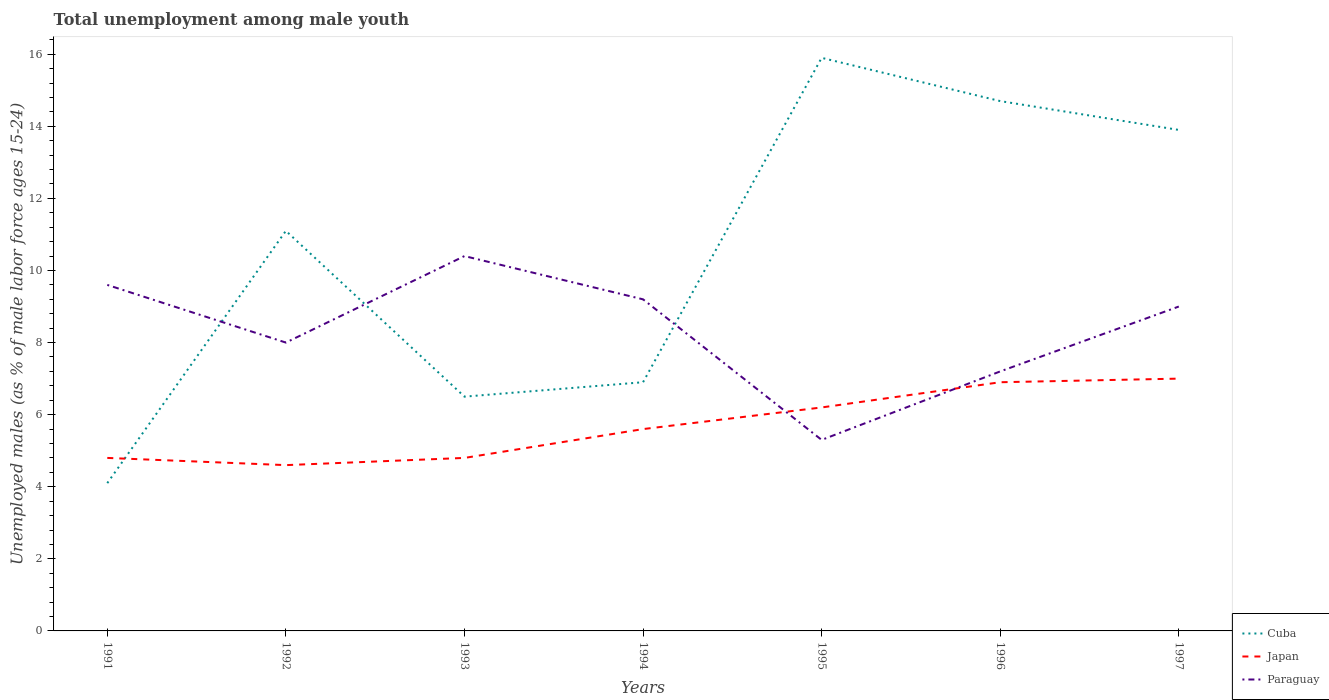Does the line corresponding to Paraguay intersect with the line corresponding to Cuba?
Offer a terse response. Yes. Is the number of lines equal to the number of legend labels?
Your answer should be compact. Yes. Across all years, what is the maximum percentage of unemployed males in in Cuba?
Give a very brief answer. 4.1. In which year was the percentage of unemployed males in in Japan maximum?
Provide a succinct answer. 1992. What is the difference between the highest and the second highest percentage of unemployed males in in Cuba?
Make the answer very short. 11.8. How many lines are there?
Provide a short and direct response. 3. How are the legend labels stacked?
Provide a short and direct response. Vertical. What is the title of the graph?
Provide a short and direct response. Total unemployment among male youth. Does "Kyrgyz Republic" appear as one of the legend labels in the graph?
Your response must be concise. No. What is the label or title of the Y-axis?
Offer a terse response. Unemployed males (as % of male labor force ages 15-24). What is the Unemployed males (as % of male labor force ages 15-24) in Cuba in 1991?
Your answer should be compact. 4.1. What is the Unemployed males (as % of male labor force ages 15-24) of Japan in 1991?
Give a very brief answer. 4.8. What is the Unemployed males (as % of male labor force ages 15-24) in Paraguay in 1991?
Ensure brevity in your answer.  9.6. What is the Unemployed males (as % of male labor force ages 15-24) in Cuba in 1992?
Give a very brief answer. 11.1. What is the Unemployed males (as % of male labor force ages 15-24) of Japan in 1992?
Your answer should be compact. 4.6. What is the Unemployed males (as % of male labor force ages 15-24) in Paraguay in 1992?
Your response must be concise. 8. What is the Unemployed males (as % of male labor force ages 15-24) of Japan in 1993?
Keep it short and to the point. 4.8. What is the Unemployed males (as % of male labor force ages 15-24) in Paraguay in 1993?
Offer a very short reply. 10.4. What is the Unemployed males (as % of male labor force ages 15-24) in Cuba in 1994?
Provide a short and direct response. 6.9. What is the Unemployed males (as % of male labor force ages 15-24) of Japan in 1994?
Give a very brief answer. 5.6. What is the Unemployed males (as % of male labor force ages 15-24) in Paraguay in 1994?
Provide a succinct answer. 9.2. What is the Unemployed males (as % of male labor force ages 15-24) of Cuba in 1995?
Offer a very short reply. 15.9. What is the Unemployed males (as % of male labor force ages 15-24) in Japan in 1995?
Provide a short and direct response. 6.2. What is the Unemployed males (as % of male labor force ages 15-24) in Paraguay in 1995?
Make the answer very short. 5.3. What is the Unemployed males (as % of male labor force ages 15-24) of Cuba in 1996?
Provide a short and direct response. 14.7. What is the Unemployed males (as % of male labor force ages 15-24) in Japan in 1996?
Your response must be concise. 6.9. What is the Unemployed males (as % of male labor force ages 15-24) of Paraguay in 1996?
Your response must be concise. 7.2. What is the Unemployed males (as % of male labor force ages 15-24) of Cuba in 1997?
Provide a succinct answer. 13.9. What is the Unemployed males (as % of male labor force ages 15-24) of Paraguay in 1997?
Offer a very short reply. 9. Across all years, what is the maximum Unemployed males (as % of male labor force ages 15-24) in Cuba?
Offer a terse response. 15.9. Across all years, what is the maximum Unemployed males (as % of male labor force ages 15-24) in Paraguay?
Ensure brevity in your answer.  10.4. Across all years, what is the minimum Unemployed males (as % of male labor force ages 15-24) in Cuba?
Provide a succinct answer. 4.1. Across all years, what is the minimum Unemployed males (as % of male labor force ages 15-24) in Japan?
Your answer should be very brief. 4.6. Across all years, what is the minimum Unemployed males (as % of male labor force ages 15-24) in Paraguay?
Your response must be concise. 5.3. What is the total Unemployed males (as % of male labor force ages 15-24) of Cuba in the graph?
Provide a short and direct response. 73.1. What is the total Unemployed males (as % of male labor force ages 15-24) in Japan in the graph?
Offer a very short reply. 39.9. What is the total Unemployed males (as % of male labor force ages 15-24) in Paraguay in the graph?
Give a very brief answer. 58.7. What is the difference between the Unemployed males (as % of male labor force ages 15-24) of Cuba in 1991 and that in 1994?
Keep it short and to the point. -2.8. What is the difference between the Unemployed males (as % of male labor force ages 15-24) in Japan in 1991 and that in 1994?
Keep it short and to the point. -0.8. What is the difference between the Unemployed males (as % of male labor force ages 15-24) in Paraguay in 1991 and that in 1994?
Ensure brevity in your answer.  0.4. What is the difference between the Unemployed males (as % of male labor force ages 15-24) in Cuba in 1991 and that in 1995?
Provide a short and direct response. -11.8. What is the difference between the Unemployed males (as % of male labor force ages 15-24) of Japan in 1991 and that in 1996?
Your answer should be very brief. -2.1. What is the difference between the Unemployed males (as % of male labor force ages 15-24) in Cuba in 1991 and that in 1997?
Your answer should be very brief. -9.8. What is the difference between the Unemployed males (as % of male labor force ages 15-24) of Japan in 1991 and that in 1997?
Offer a terse response. -2.2. What is the difference between the Unemployed males (as % of male labor force ages 15-24) of Paraguay in 1991 and that in 1997?
Give a very brief answer. 0.6. What is the difference between the Unemployed males (as % of male labor force ages 15-24) in Japan in 1992 and that in 1993?
Keep it short and to the point. -0.2. What is the difference between the Unemployed males (as % of male labor force ages 15-24) in Cuba in 1992 and that in 1994?
Offer a very short reply. 4.2. What is the difference between the Unemployed males (as % of male labor force ages 15-24) of Japan in 1992 and that in 1994?
Keep it short and to the point. -1. What is the difference between the Unemployed males (as % of male labor force ages 15-24) in Paraguay in 1992 and that in 1994?
Make the answer very short. -1.2. What is the difference between the Unemployed males (as % of male labor force ages 15-24) of Cuba in 1992 and that in 1995?
Give a very brief answer. -4.8. What is the difference between the Unemployed males (as % of male labor force ages 15-24) of Japan in 1992 and that in 1995?
Make the answer very short. -1.6. What is the difference between the Unemployed males (as % of male labor force ages 15-24) of Cuba in 1992 and that in 1996?
Give a very brief answer. -3.6. What is the difference between the Unemployed males (as % of male labor force ages 15-24) of Paraguay in 1992 and that in 1996?
Your answer should be compact. 0.8. What is the difference between the Unemployed males (as % of male labor force ages 15-24) in Cuba in 1993 and that in 1994?
Provide a short and direct response. -0.4. What is the difference between the Unemployed males (as % of male labor force ages 15-24) in Paraguay in 1993 and that in 1994?
Your answer should be very brief. 1.2. What is the difference between the Unemployed males (as % of male labor force ages 15-24) in Japan in 1993 and that in 1995?
Ensure brevity in your answer.  -1.4. What is the difference between the Unemployed males (as % of male labor force ages 15-24) in Japan in 1993 and that in 1996?
Your answer should be very brief. -2.1. What is the difference between the Unemployed males (as % of male labor force ages 15-24) of Paraguay in 1993 and that in 1996?
Make the answer very short. 3.2. What is the difference between the Unemployed males (as % of male labor force ages 15-24) of Cuba in 1993 and that in 1997?
Make the answer very short. -7.4. What is the difference between the Unemployed males (as % of male labor force ages 15-24) of Japan in 1994 and that in 1995?
Offer a very short reply. -0.6. What is the difference between the Unemployed males (as % of male labor force ages 15-24) of Paraguay in 1994 and that in 1995?
Give a very brief answer. 3.9. What is the difference between the Unemployed males (as % of male labor force ages 15-24) in Cuba in 1994 and that in 1996?
Make the answer very short. -7.8. What is the difference between the Unemployed males (as % of male labor force ages 15-24) of Japan in 1994 and that in 1996?
Offer a very short reply. -1.3. What is the difference between the Unemployed males (as % of male labor force ages 15-24) of Paraguay in 1994 and that in 1996?
Offer a terse response. 2. What is the difference between the Unemployed males (as % of male labor force ages 15-24) in Cuba in 1994 and that in 1997?
Provide a succinct answer. -7. What is the difference between the Unemployed males (as % of male labor force ages 15-24) of Japan in 1995 and that in 1996?
Offer a very short reply. -0.7. What is the difference between the Unemployed males (as % of male labor force ages 15-24) of Paraguay in 1995 and that in 1996?
Your response must be concise. -1.9. What is the difference between the Unemployed males (as % of male labor force ages 15-24) in Paraguay in 1995 and that in 1997?
Your response must be concise. -3.7. What is the difference between the Unemployed males (as % of male labor force ages 15-24) in Cuba in 1996 and that in 1997?
Provide a succinct answer. 0.8. What is the difference between the Unemployed males (as % of male labor force ages 15-24) of Japan in 1996 and that in 1997?
Provide a succinct answer. -0.1. What is the difference between the Unemployed males (as % of male labor force ages 15-24) of Cuba in 1991 and the Unemployed males (as % of male labor force ages 15-24) of Paraguay in 1992?
Keep it short and to the point. -3.9. What is the difference between the Unemployed males (as % of male labor force ages 15-24) of Japan in 1991 and the Unemployed males (as % of male labor force ages 15-24) of Paraguay in 1992?
Make the answer very short. -3.2. What is the difference between the Unemployed males (as % of male labor force ages 15-24) in Japan in 1991 and the Unemployed males (as % of male labor force ages 15-24) in Paraguay in 1993?
Offer a terse response. -5.6. What is the difference between the Unemployed males (as % of male labor force ages 15-24) of Cuba in 1991 and the Unemployed males (as % of male labor force ages 15-24) of Japan in 1994?
Make the answer very short. -1.5. What is the difference between the Unemployed males (as % of male labor force ages 15-24) of Cuba in 1991 and the Unemployed males (as % of male labor force ages 15-24) of Paraguay in 1994?
Keep it short and to the point. -5.1. What is the difference between the Unemployed males (as % of male labor force ages 15-24) in Japan in 1991 and the Unemployed males (as % of male labor force ages 15-24) in Paraguay in 1994?
Your answer should be compact. -4.4. What is the difference between the Unemployed males (as % of male labor force ages 15-24) of Cuba in 1991 and the Unemployed males (as % of male labor force ages 15-24) of Paraguay in 1995?
Make the answer very short. -1.2. What is the difference between the Unemployed males (as % of male labor force ages 15-24) in Japan in 1991 and the Unemployed males (as % of male labor force ages 15-24) in Paraguay in 1995?
Give a very brief answer. -0.5. What is the difference between the Unemployed males (as % of male labor force ages 15-24) in Cuba in 1991 and the Unemployed males (as % of male labor force ages 15-24) in Japan in 1996?
Offer a terse response. -2.8. What is the difference between the Unemployed males (as % of male labor force ages 15-24) of Cuba in 1991 and the Unemployed males (as % of male labor force ages 15-24) of Paraguay in 1996?
Offer a very short reply. -3.1. What is the difference between the Unemployed males (as % of male labor force ages 15-24) in Japan in 1991 and the Unemployed males (as % of male labor force ages 15-24) in Paraguay in 1996?
Provide a succinct answer. -2.4. What is the difference between the Unemployed males (as % of male labor force ages 15-24) of Cuba in 1991 and the Unemployed males (as % of male labor force ages 15-24) of Japan in 1997?
Provide a short and direct response. -2.9. What is the difference between the Unemployed males (as % of male labor force ages 15-24) in Cuba in 1991 and the Unemployed males (as % of male labor force ages 15-24) in Paraguay in 1997?
Give a very brief answer. -4.9. What is the difference between the Unemployed males (as % of male labor force ages 15-24) of Japan in 1991 and the Unemployed males (as % of male labor force ages 15-24) of Paraguay in 1997?
Ensure brevity in your answer.  -4.2. What is the difference between the Unemployed males (as % of male labor force ages 15-24) in Cuba in 1992 and the Unemployed males (as % of male labor force ages 15-24) in Japan in 1995?
Your answer should be very brief. 4.9. What is the difference between the Unemployed males (as % of male labor force ages 15-24) of Cuba in 1992 and the Unemployed males (as % of male labor force ages 15-24) of Paraguay in 1995?
Ensure brevity in your answer.  5.8. What is the difference between the Unemployed males (as % of male labor force ages 15-24) of Japan in 1992 and the Unemployed males (as % of male labor force ages 15-24) of Paraguay in 1995?
Offer a very short reply. -0.7. What is the difference between the Unemployed males (as % of male labor force ages 15-24) of Cuba in 1992 and the Unemployed males (as % of male labor force ages 15-24) of Paraguay in 1996?
Ensure brevity in your answer.  3.9. What is the difference between the Unemployed males (as % of male labor force ages 15-24) of Japan in 1992 and the Unemployed males (as % of male labor force ages 15-24) of Paraguay in 1996?
Provide a short and direct response. -2.6. What is the difference between the Unemployed males (as % of male labor force ages 15-24) in Cuba in 1992 and the Unemployed males (as % of male labor force ages 15-24) in Japan in 1997?
Ensure brevity in your answer.  4.1. What is the difference between the Unemployed males (as % of male labor force ages 15-24) of Japan in 1992 and the Unemployed males (as % of male labor force ages 15-24) of Paraguay in 1997?
Your answer should be very brief. -4.4. What is the difference between the Unemployed males (as % of male labor force ages 15-24) in Cuba in 1993 and the Unemployed males (as % of male labor force ages 15-24) in Paraguay in 1994?
Give a very brief answer. -2.7. What is the difference between the Unemployed males (as % of male labor force ages 15-24) of Cuba in 1993 and the Unemployed males (as % of male labor force ages 15-24) of Japan in 1996?
Give a very brief answer. -0.4. What is the difference between the Unemployed males (as % of male labor force ages 15-24) of Cuba in 1993 and the Unemployed males (as % of male labor force ages 15-24) of Paraguay in 1996?
Keep it short and to the point. -0.7. What is the difference between the Unemployed males (as % of male labor force ages 15-24) of Cuba in 1993 and the Unemployed males (as % of male labor force ages 15-24) of Paraguay in 1997?
Give a very brief answer. -2.5. What is the difference between the Unemployed males (as % of male labor force ages 15-24) of Japan in 1993 and the Unemployed males (as % of male labor force ages 15-24) of Paraguay in 1997?
Your answer should be very brief. -4.2. What is the difference between the Unemployed males (as % of male labor force ages 15-24) of Japan in 1994 and the Unemployed males (as % of male labor force ages 15-24) of Paraguay in 1995?
Give a very brief answer. 0.3. What is the difference between the Unemployed males (as % of male labor force ages 15-24) in Cuba in 1994 and the Unemployed males (as % of male labor force ages 15-24) in Paraguay in 1996?
Offer a very short reply. -0.3. What is the difference between the Unemployed males (as % of male labor force ages 15-24) in Cuba in 1994 and the Unemployed males (as % of male labor force ages 15-24) in Paraguay in 1997?
Your response must be concise. -2.1. What is the difference between the Unemployed males (as % of male labor force ages 15-24) in Cuba in 1995 and the Unemployed males (as % of male labor force ages 15-24) in Japan in 1997?
Provide a short and direct response. 8.9. What is the difference between the Unemployed males (as % of male labor force ages 15-24) of Japan in 1995 and the Unemployed males (as % of male labor force ages 15-24) of Paraguay in 1997?
Keep it short and to the point. -2.8. What is the difference between the Unemployed males (as % of male labor force ages 15-24) of Cuba in 1996 and the Unemployed males (as % of male labor force ages 15-24) of Japan in 1997?
Provide a succinct answer. 7.7. What is the difference between the Unemployed males (as % of male labor force ages 15-24) in Cuba in 1996 and the Unemployed males (as % of male labor force ages 15-24) in Paraguay in 1997?
Give a very brief answer. 5.7. What is the average Unemployed males (as % of male labor force ages 15-24) of Cuba per year?
Provide a succinct answer. 10.44. What is the average Unemployed males (as % of male labor force ages 15-24) in Paraguay per year?
Make the answer very short. 8.39. In the year 1991, what is the difference between the Unemployed males (as % of male labor force ages 15-24) of Cuba and Unemployed males (as % of male labor force ages 15-24) of Japan?
Keep it short and to the point. -0.7. In the year 1992, what is the difference between the Unemployed males (as % of male labor force ages 15-24) of Cuba and Unemployed males (as % of male labor force ages 15-24) of Paraguay?
Keep it short and to the point. 3.1. In the year 1992, what is the difference between the Unemployed males (as % of male labor force ages 15-24) of Japan and Unemployed males (as % of male labor force ages 15-24) of Paraguay?
Your answer should be compact. -3.4. In the year 1994, what is the difference between the Unemployed males (as % of male labor force ages 15-24) of Cuba and Unemployed males (as % of male labor force ages 15-24) of Japan?
Your response must be concise. 1.3. In the year 1995, what is the difference between the Unemployed males (as % of male labor force ages 15-24) of Cuba and Unemployed males (as % of male labor force ages 15-24) of Japan?
Offer a very short reply. 9.7. In the year 1996, what is the difference between the Unemployed males (as % of male labor force ages 15-24) in Cuba and Unemployed males (as % of male labor force ages 15-24) in Japan?
Give a very brief answer. 7.8. In the year 1997, what is the difference between the Unemployed males (as % of male labor force ages 15-24) in Cuba and Unemployed males (as % of male labor force ages 15-24) in Paraguay?
Your response must be concise. 4.9. In the year 1997, what is the difference between the Unemployed males (as % of male labor force ages 15-24) in Japan and Unemployed males (as % of male labor force ages 15-24) in Paraguay?
Your response must be concise. -2. What is the ratio of the Unemployed males (as % of male labor force ages 15-24) in Cuba in 1991 to that in 1992?
Your answer should be compact. 0.37. What is the ratio of the Unemployed males (as % of male labor force ages 15-24) in Japan in 1991 to that in 1992?
Your answer should be very brief. 1.04. What is the ratio of the Unemployed males (as % of male labor force ages 15-24) of Paraguay in 1991 to that in 1992?
Give a very brief answer. 1.2. What is the ratio of the Unemployed males (as % of male labor force ages 15-24) in Cuba in 1991 to that in 1993?
Provide a succinct answer. 0.63. What is the ratio of the Unemployed males (as % of male labor force ages 15-24) in Japan in 1991 to that in 1993?
Offer a terse response. 1. What is the ratio of the Unemployed males (as % of male labor force ages 15-24) of Paraguay in 1991 to that in 1993?
Make the answer very short. 0.92. What is the ratio of the Unemployed males (as % of male labor force ages 15-24) in Cuba in 1991 to that in 1994?
Your answer should be very brief. 0.59. What is the ratio of the Unemployed males (as % of male labor force ages 15-24) in Paraguay in 1991 to that in 1994?
Make the answer very short. 1.04. What is the ratio of the Unemployed males (as % of male labor force ages 15-24) of Cuba in 1991 to that in 1995?
Keep it short and to the point. 0.26. What is the ratio of the Unemployed males (as % of male labor force ages 15-24) of Japan in 1991 to that in 1995?
Provide a short and direct response. 0.77. What is the ratio of the Unemployed males (as % of male labor force ages 15-24) of Paraguay in 1991 to that in 1995?
Your response must be concise. 1.81. What is the ratio of the Unemployed males (as % of male labor force ages 15-24) in Cuba in 1991 to that in 1996?
Provide a short and direct response. 0.28. What is the ratio of the Unemployed males (as % of male labor force ages 15-24) in Japan in 1991 to that in 1996?
Your response must be concise. 0.7. What is the ratio of the Unemployed males (as % of male labor force ages 15-24) in Paraguay in 1991 to that in 1996?
Give a very brief answer. 1.33. What is the ratio of the Unemployed males (as % of male labor force ages 15-24) of Cuba in 1991 to that in 1997?
Your response must be concise. 0.29. What is the ratio of the Unemployed males (as % of male labor force ages 15-24) of Japan in 1991 to that in 1997?
Ensure brevity in your answer.  0.69. What is the ratio of the Unemployed males (as % of male labor force ages 15-24) of Paraguay in 1991 to that in 1997?
Give a very brief answer. 1.07. What is the ratio of the Unemployed males (as % of male labor force ages 15-24) in Cuba in 1992 to that in 1993?
Offer a terse response. 1.71. What is the ratio of the Unemployed males (as % of male labor force ages 15-24) of Japan in 1992 to that in 1993?
Your answer should be very brief. 0.96. What is the ratio of the Unemployed males (as % of male labor force ages 15-24) in Paraguay in 1992 to that in 1993?
Offer a very short reply. 0.77. What is the ratio of the Unemployed males (as % of male labor force ages 15-24) in Cuba in 1992 to that in 1994?
Provide a short and direct response. 1.61. What is the ratio of the Unemployed males (as % of male labor force ages 15-24) in Japan in 1992 to that in 1994?
Give a very brief answer. 0.82. What is the ratio of the Unemployed males (as % of male labor force ages 15-24) of Paraguay in 1992 to that in 1994?
Ensure brevity in your answer.  0.87. What is the ratio of the Unemployed males (as % of male labor force ages 15-24) of Cuba in 1992 to that in 1995?
Provide a short and direct response. 0.7. What is the ratio of the Unemployed males (as % of male labor force ages 15-24) in Japan in 1992 to that in 1995?
Offer a terse response. 0.74. What is the ratio of the Unemployed males (as % of male labor force ages 15-24) of Paraguay in 1992 to that in 1995?
Provide a short and direct response. 1.51. What is the ratio of the Unemployed males (as % of male labor force ages 15-24) in Cuba in 1992 to that in 1996?
Offer a terse response. 0.76. What is the ratio of the Unemployed males (as % of male labor force ages 15-24) of Japan in 1992 to that in 1996?
Make the answer very short. 0.67. What is the ratio of the Unemployed males (as % of male labor force ages 15-24) of Paraguay in 1992 to that in 1996?
Ensure brevity in your answer.  1.11. What is the ratio of the Unemployed males (as % of male labor force ages 15-24) of Cuba in 1992 to that in 1997?
Offer a terse response. 0.8. What is the ratio of the Unemployed males (as % of male labor force ages 15-24) of Japan in 1992 to that in 1997?
Ensure brevity in your answer.  0.66. What is the ratio of the Unemployed males (as % of male labor force ages 15-24) in Cuba in 1993 to that in 1994?
Provide a succinct answer. 0.94. What is the ratio of the Unemployed males (as % of male labor force ages 15-24) of Japan in 1993 to that in 1994?
Your answer should be very brief. 0.86. What is the ratio of the Unemployed males (as % of male labor force ages 15-24) in Paraguay in 1993 to that in 1994?
Your response must be concise. 1.13. What is the ratio of the Unemployed males (as % of male labor force ages 15-24) of Cuba in 1993 to that in 1995?
Provide a succinct answer. 0.41. What is the ratio of the Unemployed males (as % of male labor force ages 15-24) of Japan in 1993 to that in 1995?
Make the answer very short. 0.77. What is the ratio of the Unemployed males (as % of male labor force ages 15-24) in Paraguay in 1993 to that in 1995?
Your answer should be compact. 1.96. What is the ratio of the Unemployed males (as % of male labor force ages 15-24) of Cuba in 1993 to that in 1996?
Your answer should be compact. 0.44. What is the ratio of the Unemployed males (as % of male labor force ages 15-24) of Japan in 1993 to that in 1996?
Your response must be concise. 0.7. What is the ratio of the Unemployed males (as % of male labor force ages 15-24) in Paraguay in 1993 to that in 1996?
Offer a terse response. 1.44. What is the ratio of the Unemployed males (as % of male labor force ages 15-24) in Cuba in 1993 to that in 1997?
Offer a terse response. 0.47. What is the ratio of the Unemployed males (as % of male labor force ages 15-24) in Japan in 1993 to that in 1997?
Provide a short and direct response. 0.69. What is the ratio of the Unemployed males (as % of male labor force ages 15-24) in Paraguay in 1993 to that in 1997?
Your response must be concise. 1.16. What is the ratio of the Unemployed males (as % of male labor force ages 15-24) in Cuba in 1994 to that in 1995?
Provide a succinct answer. 0.43. What is the ratio of the Unemployed males (as % of male labor force ages 15-24) in Japan in 1994 to that in 1995?
Keep it short and to the point. 0.9. What is the ratio of the Unemployed males (as % of male labor force ages 15-24) in Paraguay in 1994 to that in 1995?
Offer a very short reply. 1.74. What is the ratio of the Unemployed males (as % of male labor force ages 15-24) of Cuba in 1994 to that in 1996?
Provide a succinct answer. 0.47. What is the ratio of the Unemployed males (as % of male labor force ages 15-24) of Japan in 1994 to that in 1996?
Provide a short and direct response. 0.81. What is the ratio of the Unemployed males (as % of male labor force ages 15-24) of Paraguay in 1994 to that in 1996?
Offer a terse response. 1.28. What is the ratio of the Unemployed males (as % of male labor force ages 15-24) in Cuba in 1994 to that in 1997?
Keep it short and to the point. 0.5. What is the ratio of the Unemployed males (as % of male labor force ages 15-24) of Japan in 1994 to that in 1997?
Offer a terse response. 0.8. What is the ratio of the Unemployed males (as % of male labor force ages 15-24) of Paraguay in 1994 to that in 1997?
Your answer should be very brief. 1.02. What is the ratio of the Unemployed males (as % of male labor force ages 15-24) of Cuba in 1995 to that in 1996?
Offer a very short reply. 1.08. What is the ratio of the Unemployed males (as % of male labor force ages 15-24) in Japan in 1995 to that in 1996?
Your response must be concise. 0.9. What is the ratio of the Unemployed males (as % of male labor force ages 15-24) of Paraguay in 1995 to that in 1996?
Provide a short and direct response. 0.74. What is the ratio of the Unemployed males (as % of male labor force ages 15-24) of Cuba in 1995 to that in 1997?
Keep it short and to the point. 1.14. What is the ratio of the Unemployed males (as % of male labor force ages 15-24) in Japan in 1995 to that in 1997?
Your response must be concise. 0.89. What is the ratio of the Unemployed males (as % of male labor force ages 15-24) of Paraguay in 1995 to that in 1997?
Offer a terse response. 0.59. What is the ratio of the Unemployed males (as % of male labor force ages 15-24) of Cuba in 1996 to that in 1997?
Provide a short and direct response. 1.06. What is the ratio of the Unemployed males (as % of male labor force ages 15-24) of Japan in 1996 to that in 1997?
Offer a terse response. 0.99. What is the ratio of the Unemployed males (as % of male labor force ages 15-24) in Paraguay in 1996 to that in 1997?
Offer a very short reply. 0.8. What is the difference between the highest and the second highest Unemployed males (as % of male labor force ages 15-24) of Cuba?
Your answer should be very brief. 1.2. What is the difference between the highest and the lowest Unemployed males (as % of male labor force ages 15-24) in Cuba?
Give a very brief answer. 11.8. What is the difference between the highest and the lowest Unemployed males (as % of male labor force ages 15-24) of Paraguay?
Provide a succinct answer. 5.1. 